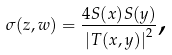Convert formula to latex. <formula><loc_0><loc_0><loc_500><loc_500>\sigma ( z , w ) = \frac { 4 S ( x ) S ( y ) } { \left | T ( x , y ) \right | ^ { 2 } } \text {,}</formula> 